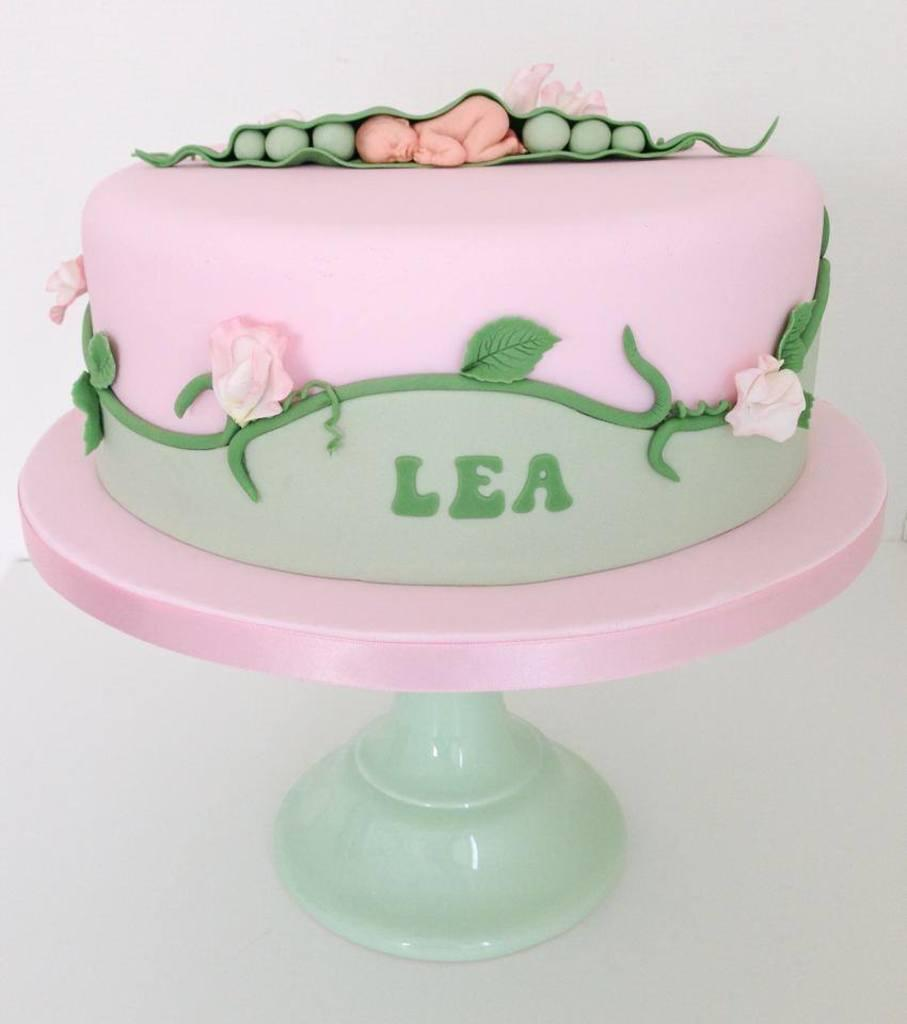What is the main subject of the image? There is a cake in the image. What colors can be seen on the cake? The cake has pink and green colors. Where is the cake located in the image? The cake is placed on a table. How does the cake contribute to harmony in the image? The cake itself does not contribute to harmony in the image, as it is an inanimate object. However, the presence of the cake might contribute to a harmonious atmosphere if it is part of a celebration or gathering. 